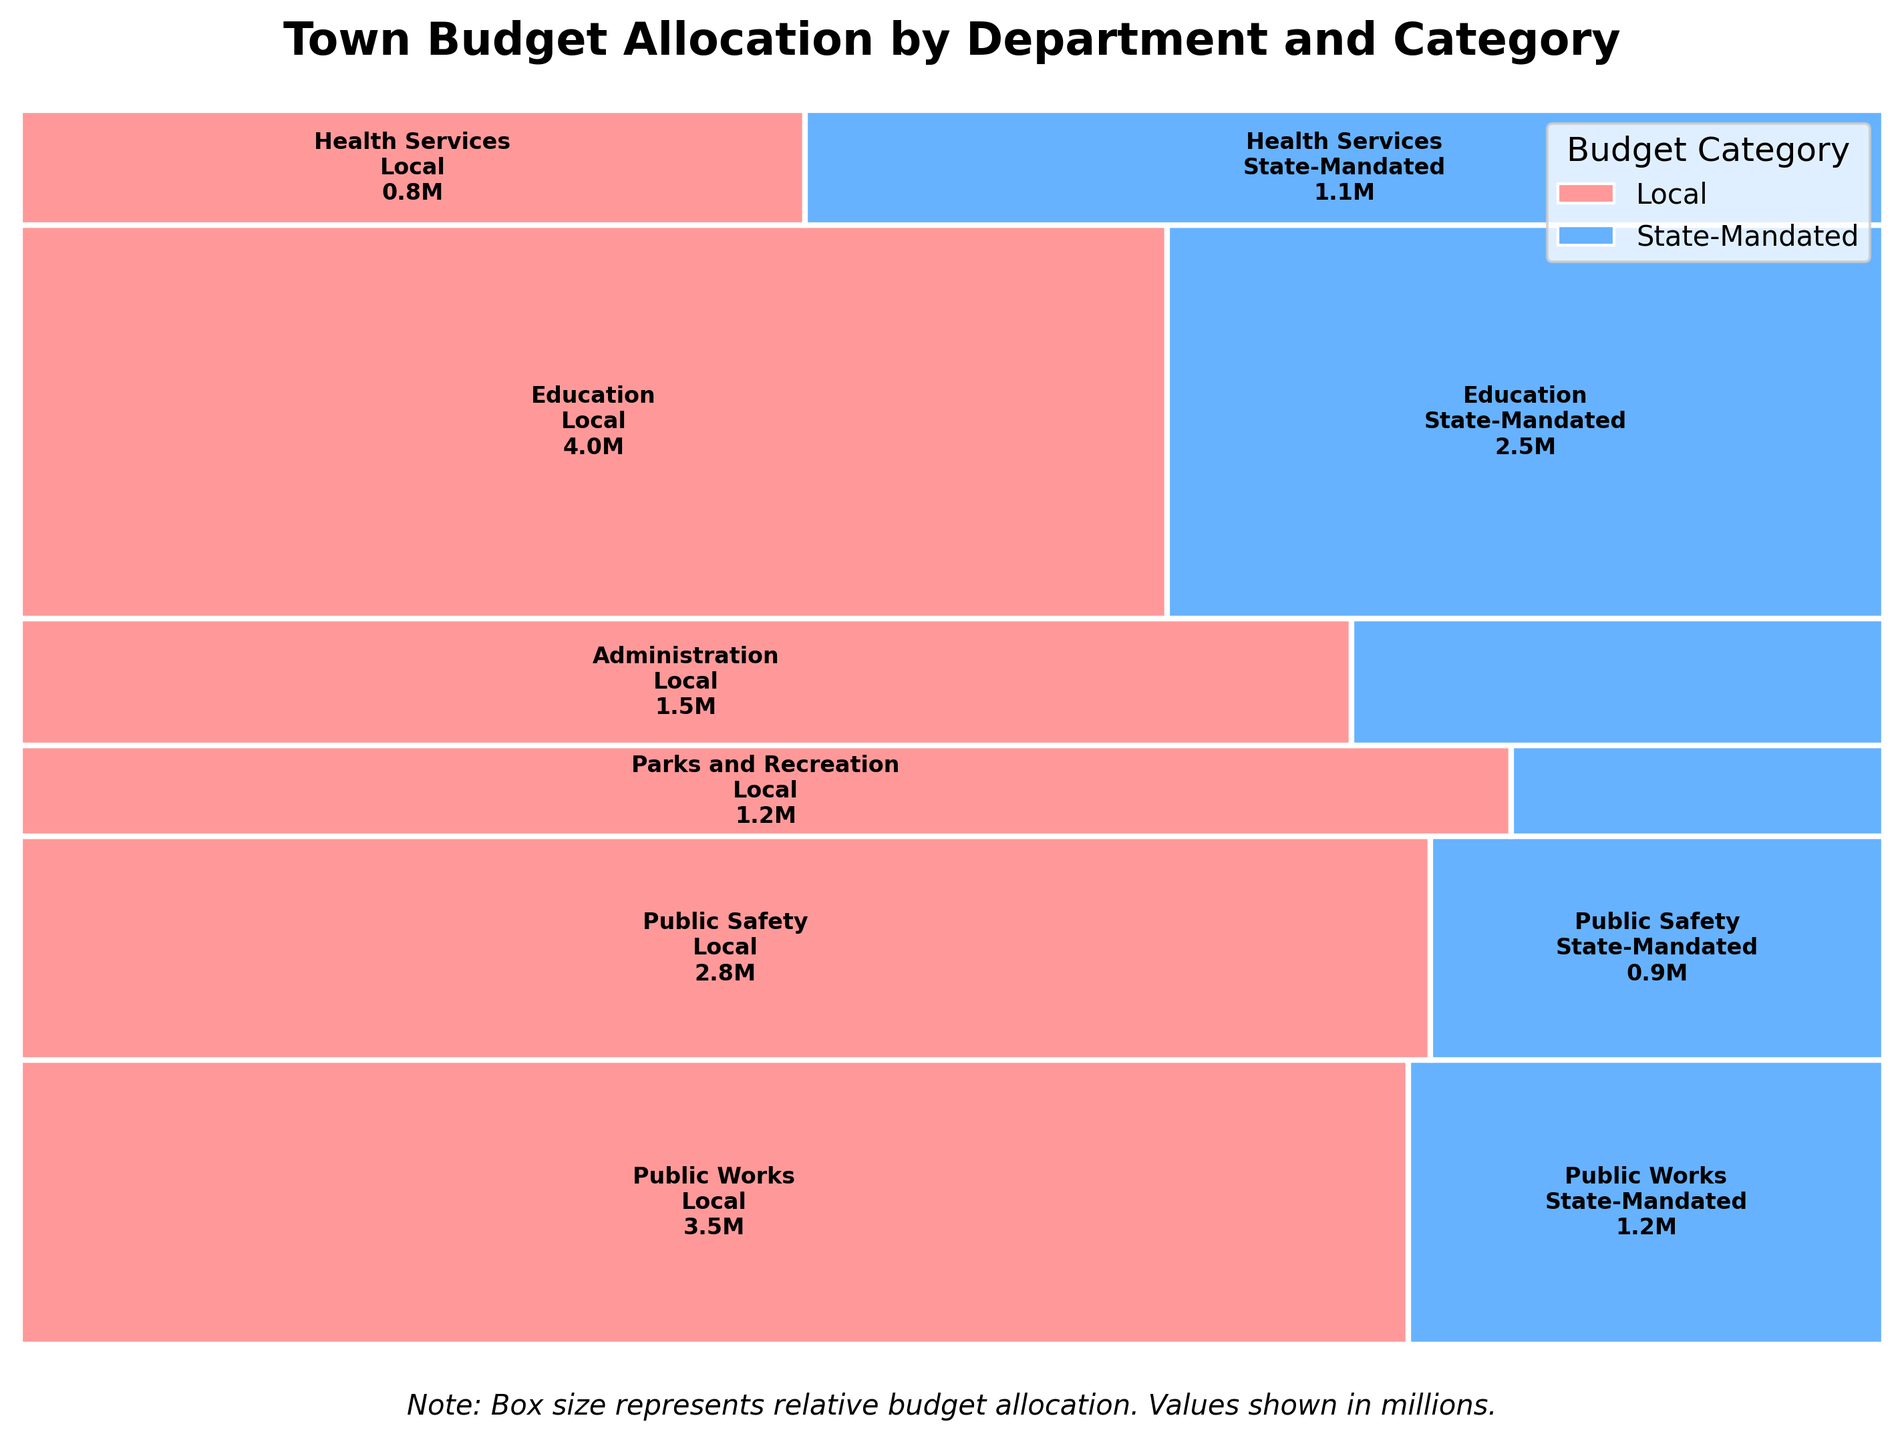What is the title of the plot? The title of the plot is usually clearly visible at the top. It gives an overview of what the plot represents by stating "Town Budget Allocation by Department and Category."
Answer: Town Budget Allocation by Department and Category Which department has the highest total allocation? Identify the tallest section in the mosaic plot, which corresponds to the department with the highest budget allocation. In this case, the tallest section represents Education.
Answer: Education How much is allocated to State-Mandated programs for Health Services? Locate the section for Health Services and then focus on the State-Mandated portion of it (likely in a different color). The figure shows the allocation of $1.1 million.
Answer: $1.1 million What percentage of the Public Works budget is allocated to Local categories? Identify the rectangles corresponding to Public Works. Calculate the width of the local category rectangle divided by the total width as shown in the plot. Here, Local allocation occupies about 74%.
Answer: 74% Which department has the smallest local allocation and how much is it? Find the smallest Local allocation rectangle, which corresponds to Health Services with an allocation of $0.8 million.
Answer: Health Services, $0.8 million Compare the total budget for Administration vs Education. Which is higher and by how much? Find the sum of the Local and State-Mandated allocations for both departments. Education has 6.5 million, and Administration has 2.1 million. The difference is 6.5 - 2.1 = 4.4 million.
Answer: Education by $4.4 million What is the proportion of the budget for Public Safety allocated to state-mandated programs? Find the section for Public Safety and calculate the width of the part allocated to state-mandated programs divided by the total width of Public Safety. It’s approximately 24%.
Answer: 24% Which section of the plot indicates the Parks and Recreation budget, and what are its internal proportions? The Parks and Recreation section can be located by looking at the labels. Determine the relative sizes of the Local and State-Mandated parts. Local is much larger than State-Mandated, approximately 80% to 20%.
Answer: Approximately 80% Local, 20% State-Mandated Among the given departments, which one receives the most funding from state-mandated programs? Compare the sizes of the State-Mandated sections across different departments. Education has the largest state-mandated allocation at $2.5 million.
Answer: Education Is the total allocation to State-Mandated programs greater than Local across all departments? Sum the total allocations of State-Mandated categories and Local categories. By comparing, we see Local allocations are higher.
Answer: No 